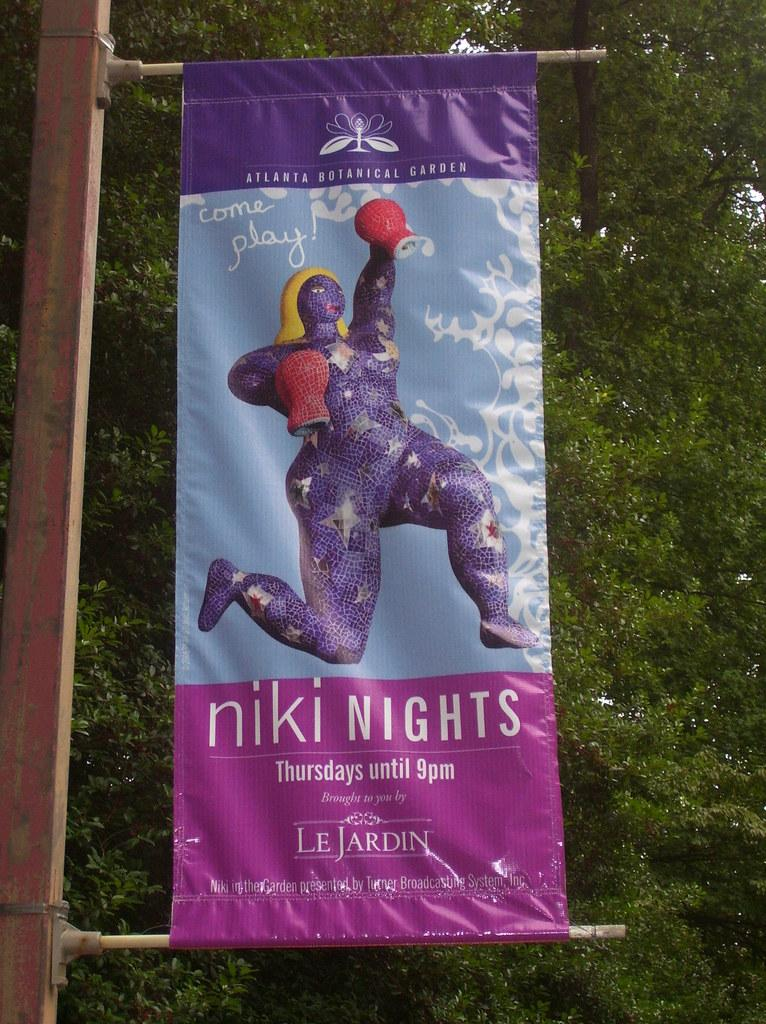Provide a one-sentence caption for the provided image. A banner for niki nights on a public pole. 